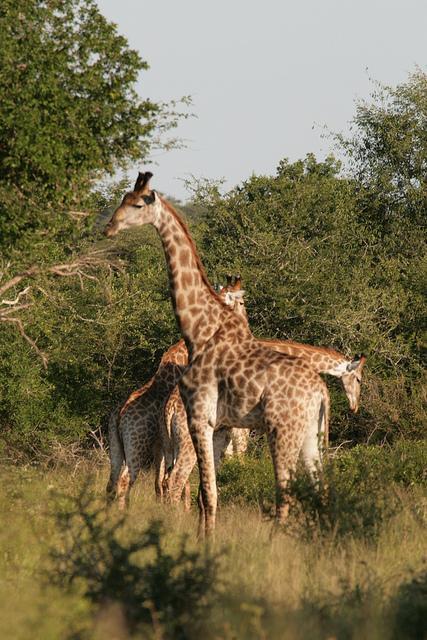How many giraffes are there?
Give a very brief answer. 3. 